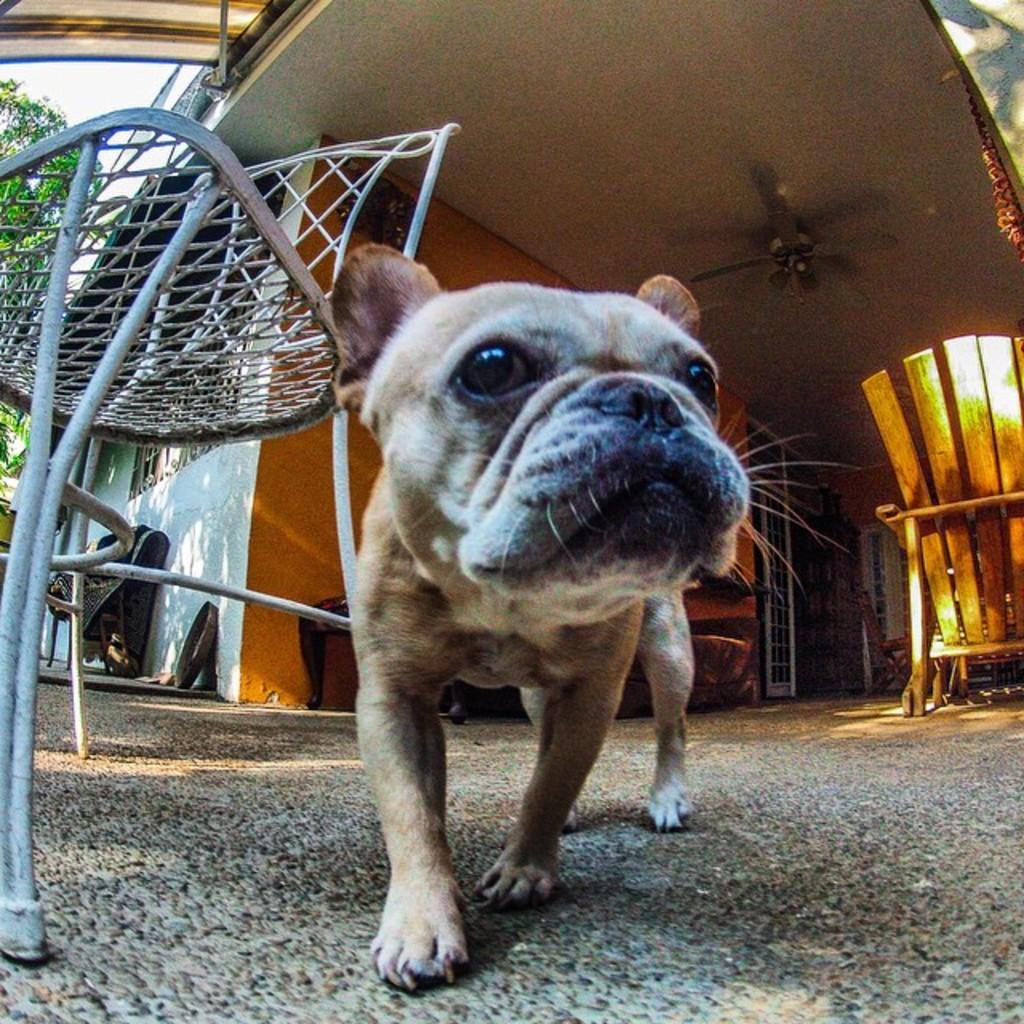What type of animal is present in the image? There is a dog in the image. What is located to the left of the dog? There is a chair to the left of the dog. What type of structure can be seen in the image? There is a building visible in the image. What is the chair on the right side of the image made of? The chair on the right side of the image is made of wood. What type of vegetation is present in the left corner of the image? There is a tree in the left corner of the image. What type of calculator is the dog using in the image? There is no calculator present in the image; it features a dog and various other objects and structures. 